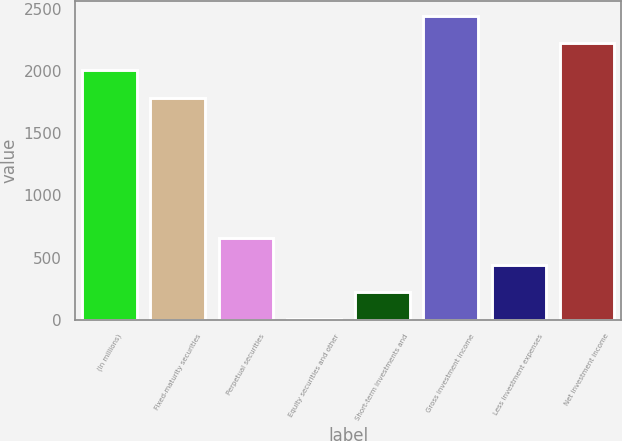Convert chart to OTSL. <chart><loc_0><loc_0><loc_500><loc_500><bar_chart><fcel>(In millions)<fcel>Fixed-maturity securities<fcel>Perpetual securities<fcel>Equity securities and other<fcel>Short-term investments and<fcel>Gross investment income<fcel>Less investment expenses<fcel>Net investment income<nl><fcel>2006<fcel>1782<fcel>658.7<fcel>2<fcel>220.9<fcel>2443.8<fcel>439.8<fcel>2224.9<nl></chart> 